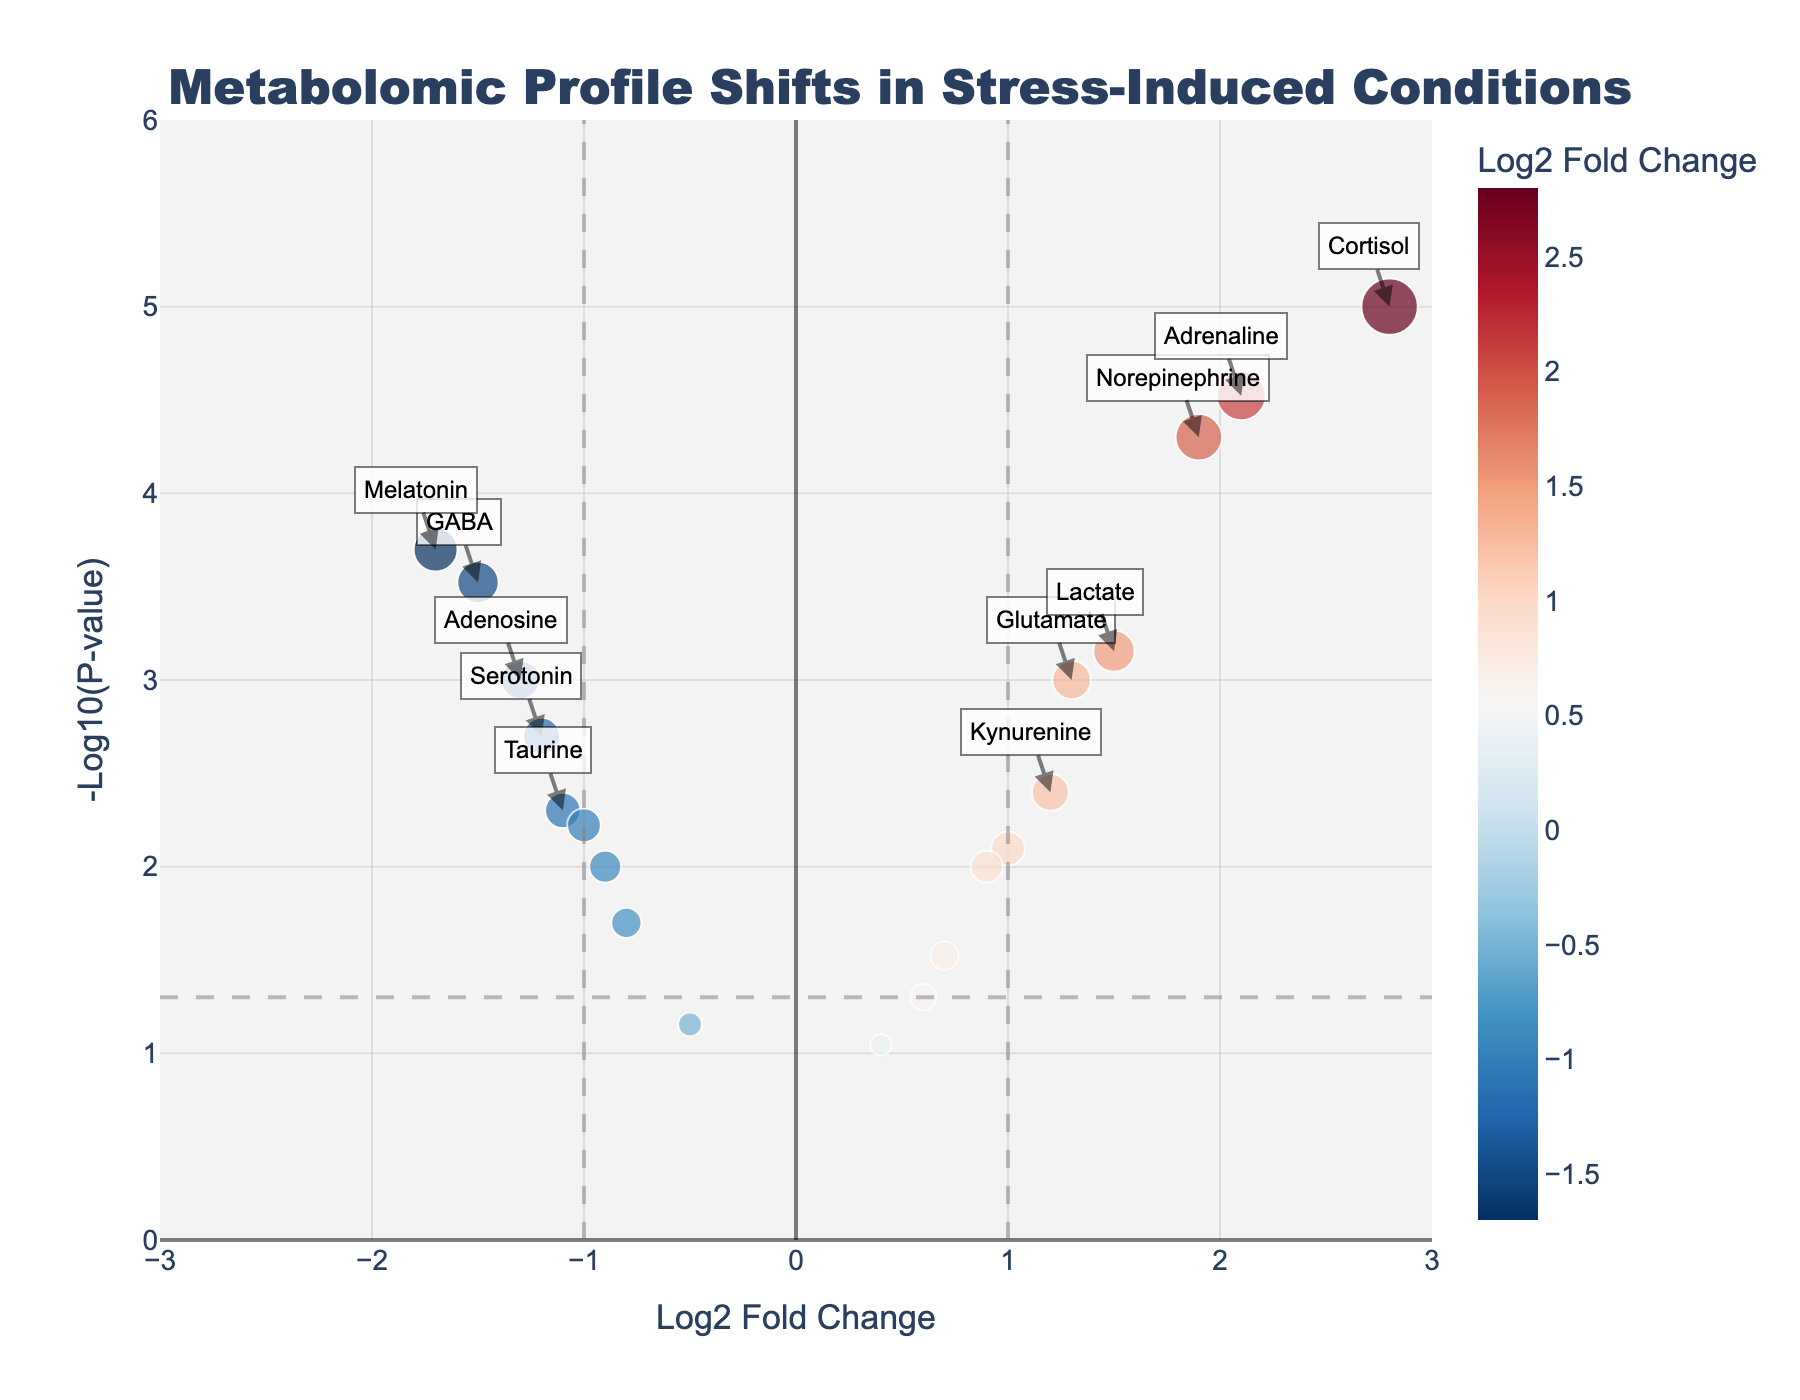What is the title of the plot? The title is the large text generally found at the top of the plot, and here it is "Metabolomic Profile Shifts in Stress-Induced Conditions."
Answer: Metabolomic Profile Shifts in Stress-Induced Conditions What do the x-axis and y-axis represent? The x-axis label is "Log2 Fold Change," indicating the change in metabolite levels due to stress. The y-axis label is "-Log10(P-value)," representing the significance of this change.
Answer: Log2 Fold Change and -Log10(P-value) Which metabolite has the highest log2 fold change? By observing the x-axis, the metabolite furthest to the right has the highest log2 fold change, which is Cortisol with a log2 fold change of 2.8.
Answer: Cortisol Which metabolite has the smallest p-value? The y-axis represents the -Log10(P-value). The highest point on the y-axis corresponds to the smallest p-value, which is 0.00001 for Cortisol.
Answer: Cortisol How many metabolites have a log2 fold change greater than 1 and a p-value less than 0.05? To answer this, look for data points that are both to the right of the vertical line at log2 fold change of 1 and above the horizontal line at -Log10(P-value) of 1.3 (since -log10(0.05) ≈ 1.3). There are 6 such metabolites.
Answer: 6 Which two metabolites have the most negative log2 fold change? Check the x-axis for the two furthest points to the left, which correspond to Melatonin (-1.7) and GABA (-1.5).
Answer: Melatonin and GABA Do any metabolites have both a log2 fold change greater than 2 and a p-value less than 0.0001? Identify any point to the right of 2 (on the x-axis) and above 4 (-log10(0.0001) = 4). The points meeting these criteria are Cortisol and Adrenaline.
Answer: Cortisol and Adrenaline What is the color indicative of on the volcano plot? The color gradient shown in the plot legend is used to represent the log2 fold change, indicating the direction and magnitude of metabolite changes.
Answer: Log2 fold change Which metabolite has a log2 fold change of exactly zero? Data points on the vertical line that intersects the y-axis at zero log2 fold change represent no change. There is no specific metabolite exactly at zero change; the closest points are near zero.
Answer: None What does an arrow on the plot represent? Arrows point to metabolites that are significantly different (log2 fold change > 1 or < -1 and p-value < 0.05), highlighting these particular data points.
Answer: Significant metabolites 